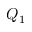Convert formula to latex. <formula><loc_0><loc_0><loc_500><loc_500>Q _ { 1 }</formula> 